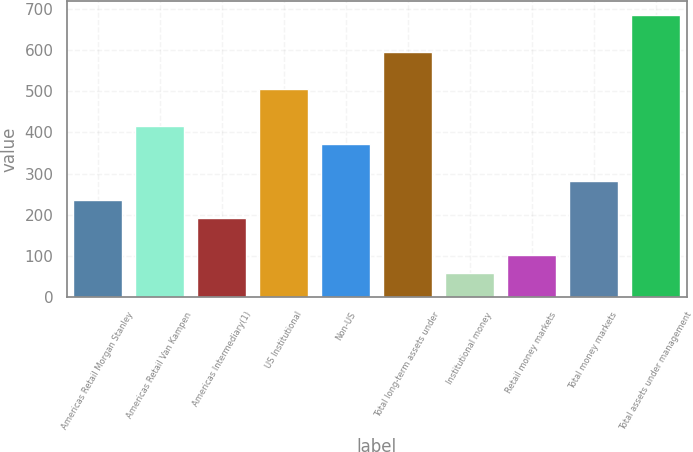Convert chart. <chart><loc_0><loc_0><loc_500><loc_500><bar_chart><fcel>Americas Retail Morgan Stanley<fcel>Americas Retail Van Kampen<fcel>Americas Intermediary(1)<fcel>US Institutional<fcel>Non-US<fcel>Total long-term assets under<fcel>Institutional money<fcel>Retail money markets<fcel>Total money markets<fcel>Total assets under management<nl><fcel>237<fcel>416.2<fcel>192.2<fcel>505.8<fcel>371.4<fcel>595.4<fcel>57.8<fcel>102.6<fcel>281.8<fcel>685<nl></chart> 